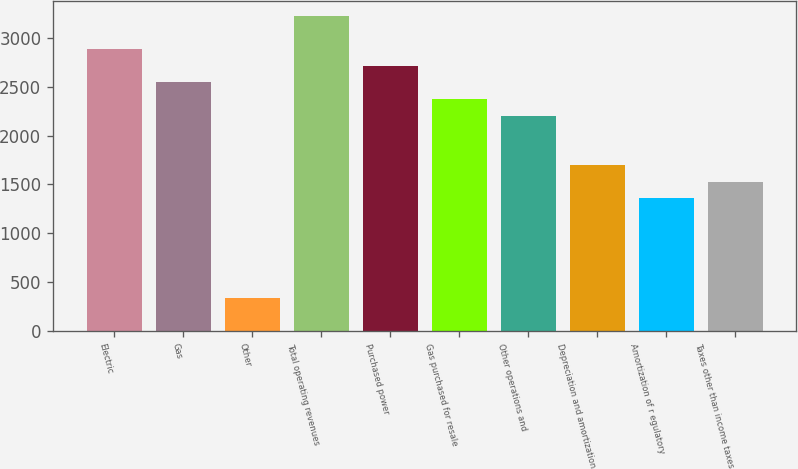<chart> <loc_0><loc_0><loc_500><loc_500><bar_chart><fcel>Electric<fcel>Gas<fcel>Other<fcel>Total operating revenues<fcel>Purchased power<fcel>Gas purchased for resale<fcel>Other operations and<fcel>Depreciation and amortization<fcel>Amortization of r egulatory<fcel>Taxes other than income taxes<nl><fcel>2881.8<fcel>2543<fcel>340.8<fcel>3220.6<fcel>2712.4<fcel>2373.6<fcel>2204.2<fcel>1696<fcel>1357.2<fcel>1526.6<nl></chart> 